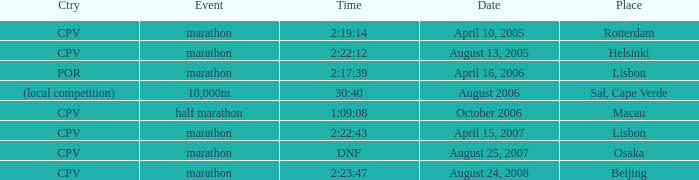Would you be able to parse every entry in this table? {'header': ['Ctry', 'Event', 'Time', 'Date', 'Place'], 'rows': [['CPV', 'marathon', '2:19:14', 'April 10, 2005', 'Rotterdam'], ['CPV', 'marathon', '2:22:12', 'August 13, 2005', 'Helsinki'], ['POR', 'marathon', '2:17:39', 'April 16, 2006', 'Lisbon'], ['(local competition)', '10,000m', '30:40', 'August 2006', 'Sal, Cape Verde'], ['CPV', 'half marathon', '1:09:08', 'October 2006', 'Macau'], ['CPV', 'marathon', '2:22:43', 'April 15, 2007', 'Lisbon'], ['CPV', 'marathon', 'DNF', 'August 25, 2007', 'Osaka'], ['CPV', 'marathon', '2:23:47', 'August 24, 2008', 'Beijing']]} What is the Country of the Half Marathon Event? CPV. 